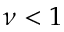Convert formula to latex. <formula><loc_0><loc_0><loc_500><loc_500>\nu < 1</formula> 